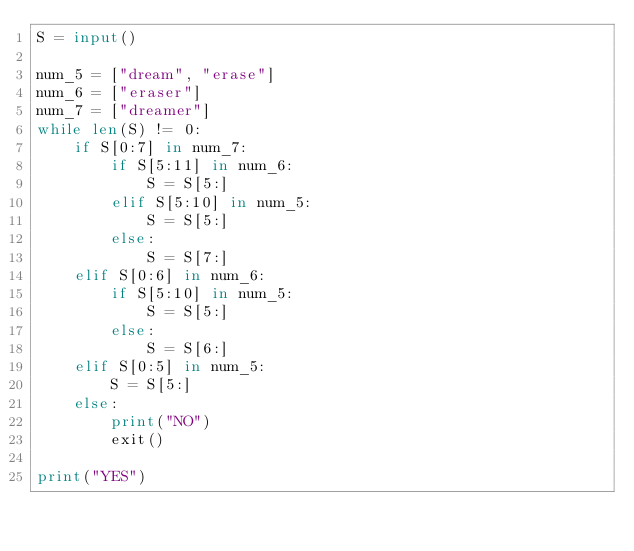<code> <loc_0><loc_0><loc_500><loc_500><_Python_>S = input()

num_5 = ["dream", "erase"]
num_6 = ["eraser"]
num_7 = ["dreamer"]
while len(S) != 0:
    if S[0:7] in num_7:
        if S[5:11] in num_6:
            S = S[5:]
        elif S[5:10] in num_5:
            S = S[5:]
        else:
            S = S[7:]
    elif S[0:6] in num_6:
        if S[5:10] in num_5:
            S = S[5:]
        else:
            S = S[6:]
    elif S[0:5] in num_5:
        S = S[5:]
    else:
        print("NO")
        exit()

print("YES")</code> 